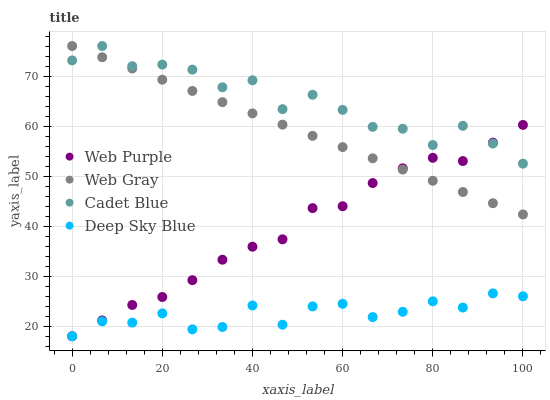Does Deep Sky Blue have the minimum area under the curve?
Answer yes or no. Yes. Does Cadet Blue have the maximum area under the curve?
Answer yes or no. Yes. Does Web Purple have the minimum area under the curve?
Answer yes or no. No. Does Web Purple have the maximum area under the curve?
Answer yes or no. No. Is Web Gray the smoothest?
Answer yes or no. Yes. Is Cadet Blue the roughest?
Answer yes or no. Yes. Is Web Purple the smoothest?
Answer yes or no. No. Is Web Purple the roughest?
Answer yes or no. No. Does Web Purple have the lowest value?
Answer yes or no. Yes. Does Web Gray have the lowest value?
Answer yes or no. No. Does Web Gray have the highest value?
Answer yes or no. Yes. Does Web Purple have the highest value?
Answer yes or no. No. Is Deep Sky Blue less than Web Gray?
Answer yes or no. Yes. Is Cadet Blue greater than Deep Sky Blue?
Answer yes or no. Yes. Does Web Gray intersect Web Purple?
Answer yes or no. Yes. Is Web Gray less than Web Purple?
Answer yes or no. No. Is Web Gray greater than Web Purple?
Answer yes or no. No. Does Deep Sky Blue intersect Web Gray?
Answer yes or no. No. 